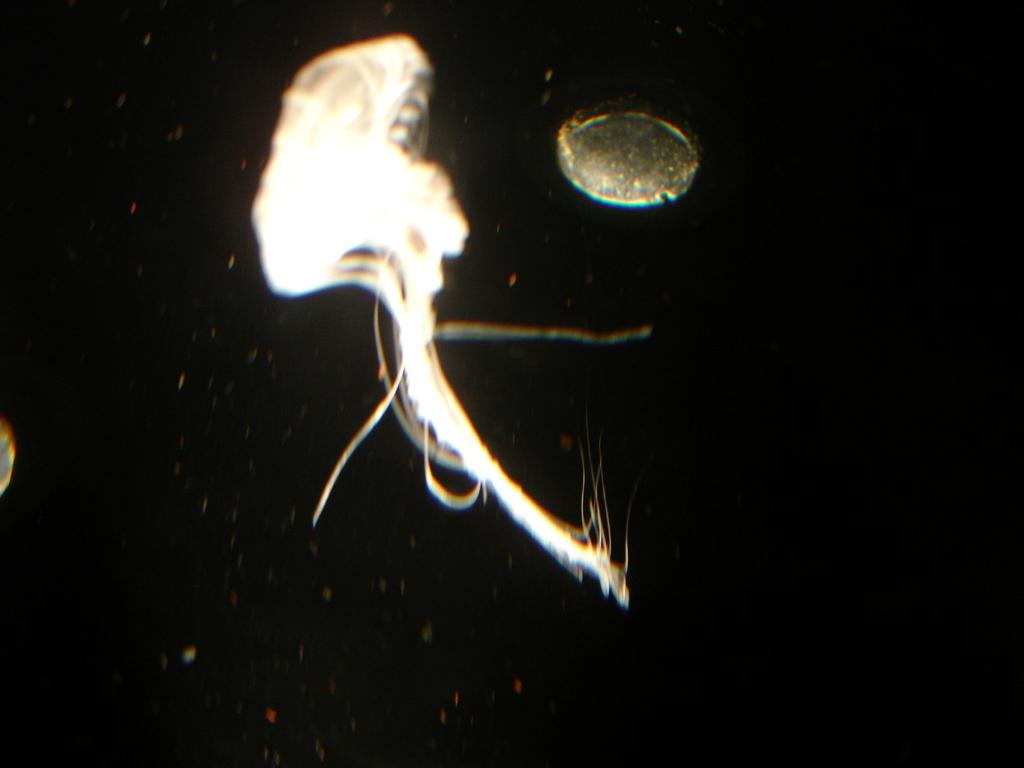What is the main subject in the center of the image? There is a jellyfish in the center of the image. What else can be seen in the image besides the jellyfish? There is another object at the top of the image. How would you describe the overall appearance of the image? The image appears to be dark. What type of paper is being used for the test in the image? There is no paper or test present in the image; it features a jellyfish and another unspecified object. How many bricks can be seen stacked in the image? There are no bricks present in the image. 